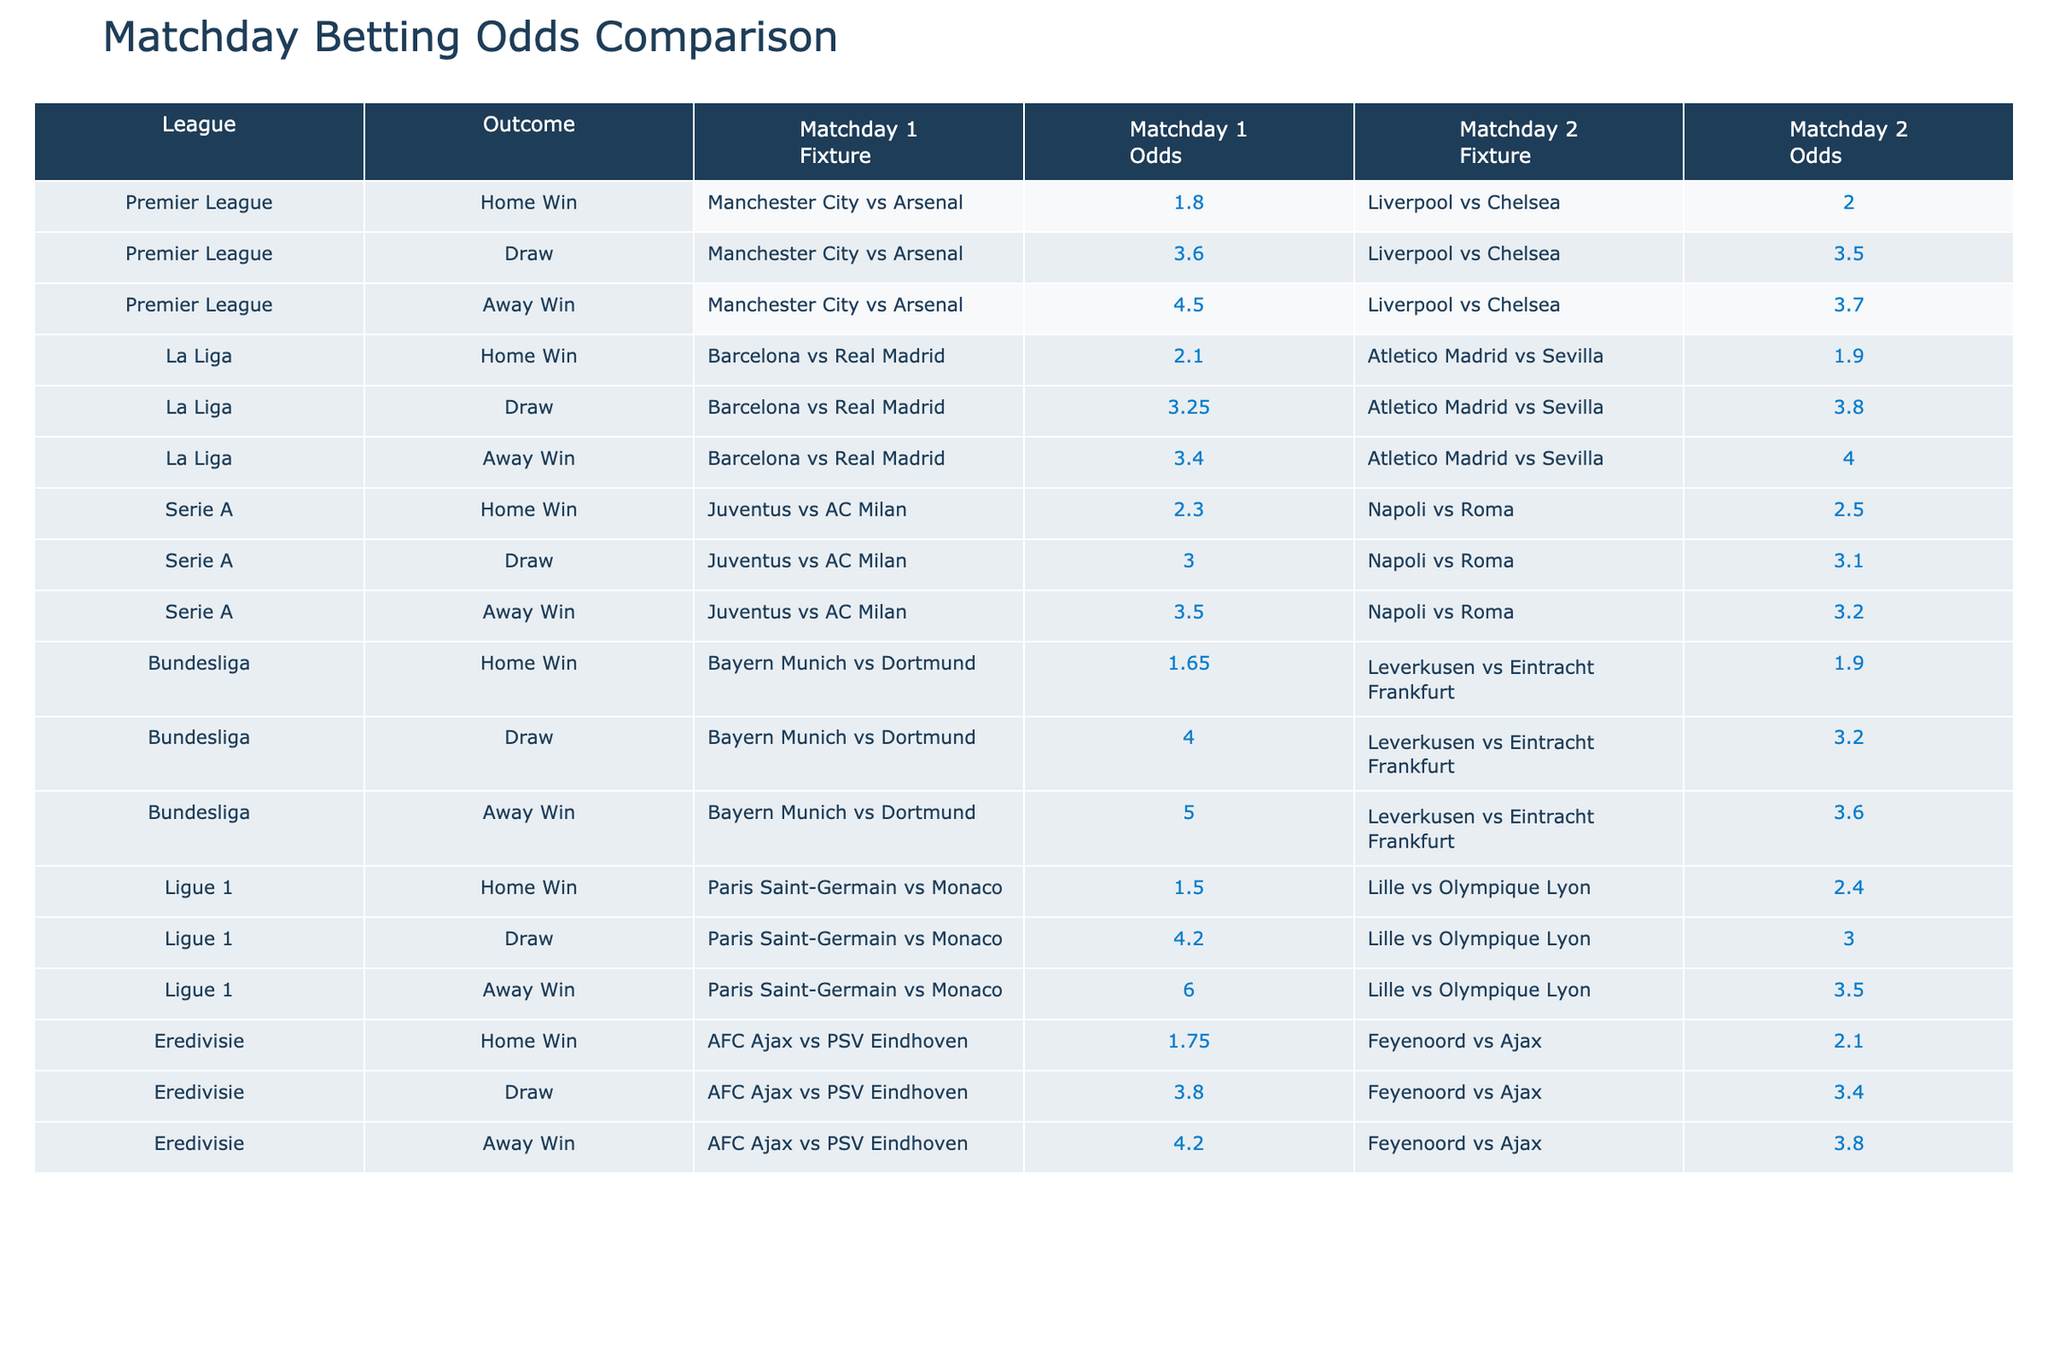What are the odds for Manchester City to win against Arsenal? The table shows that Manchester City has home win odds of 1.80 for their match against Arsenal.
Answer: 1.80 Which away team has the highest win odds in the Bundesliga? Looking at the Bundesliga row in the table, Dortmund has away win odds of 5.00, which is the highest compared to 3.60 for Eintracht Frankfurt.
Answer: Dortmund Is Napoli favored to win against Roma according to their odds? The odds for Napoli winning are 2.50, which is lower than the away win odds for Roma (3.20), meaning Napoli is favored to win.
Answer: Yes What is the average home win odds for the matches in La Liga? The home win odds for La Liga matches are 2.10 (Barcelona) and 1.90 (Atletico Madrid). The average is (2.10 + 1.90) / 2 = 2.00.
Answer: 2.00 Which league has the lowest odds for a draw? Examining all draw odds from the table, Ligue 1 (4.20) has the lowest compared to Bundesliga (4.00), Serie A (3.00), and others.
Answer: Ligue 1 What is the total of the away win odds in Serie A? The away win odds for Serie A are 3.50 (AC Milan) for Matchday 1 and 3.20 (Roma) for Matchday 2. Adding these gives 3.50 + 3.20 = 6.70.
Answer: 6.70 Was there a match with home win odds lower than 2.00 in Liga 1? In Ligue 1, the lowest home win odds are 1.50 for Paris Saint-Germain, which is indeed lower than 2.00.
Answer: Yes For which match does the away team have higher win odds than the home team? Checking the matches, the away team Monaco has odds of 6.00 while PSG's odds are 1.50, indicating Monaco's odds are higher than PSG's.
Answer: Monaco vs. PSG What match had the closest odds for home win and away win? Comparing all matches, the closest odds are for Ajax vs. PSV Eindhoven, where home odds are 1.75 and away odds are 4.20, a difference of 2.45.
Answer: Ajax vs. PSV Eindhoven 